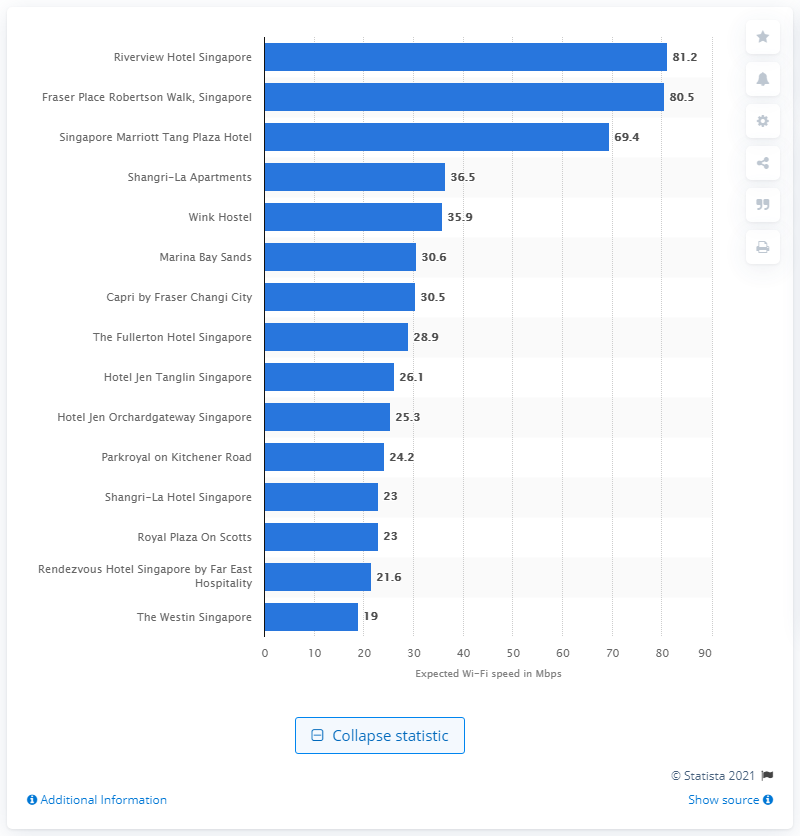Point out several critical features in this image. The Riverview Hotel Singapore was determined to have the fastest Wi-Fi out of all the hotels surveyed. 